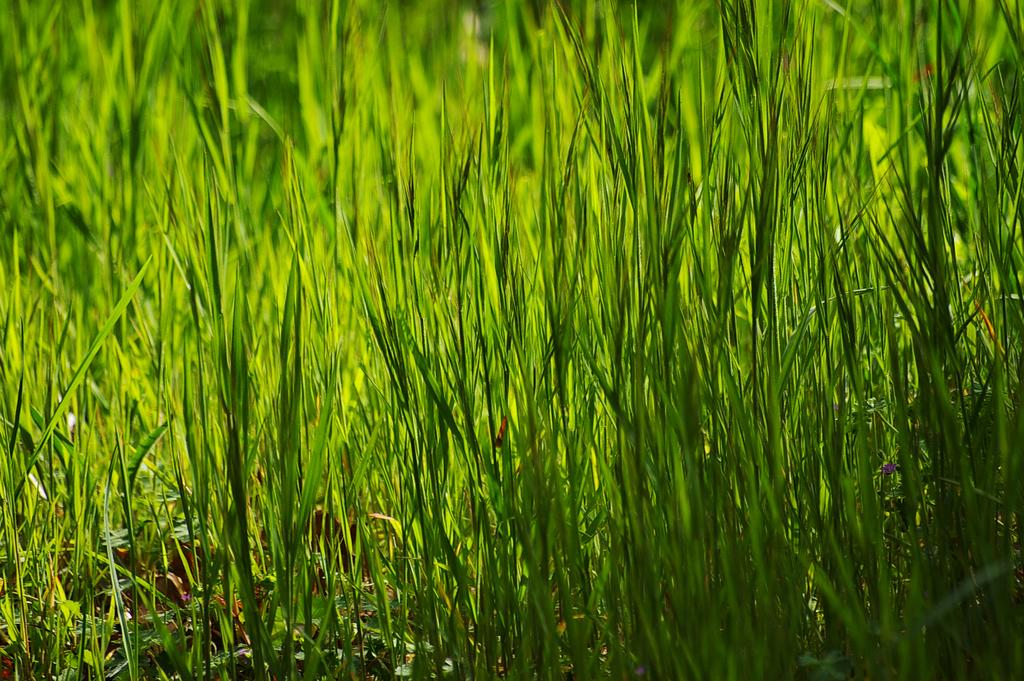What type of vegetation can be seen in the image? There is grass in the image. What is the color of the grass? The grass is green in color. Can you tell me how many friends are sitting on the grass in the image? There is no information about friends or people sitting on the grass in the image; it only shows green grass. 